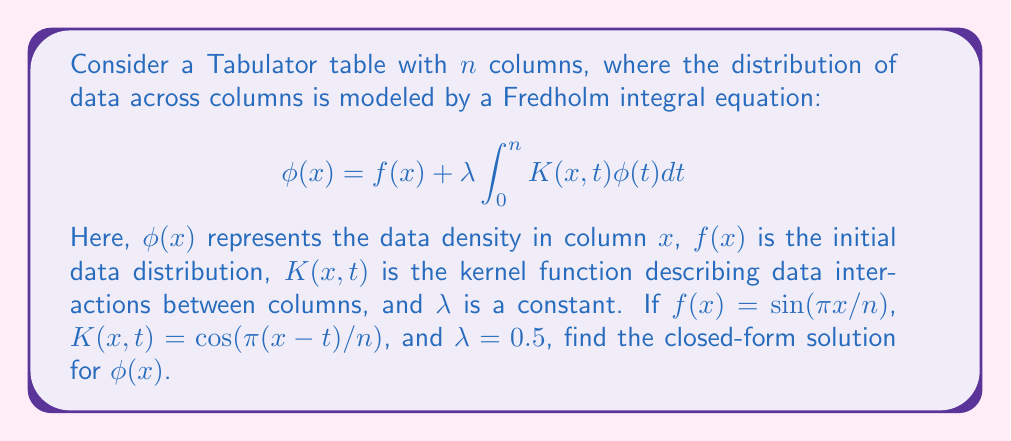Can you answer this question? To solve this Fredholm integral equation, we'll follow these steps:

1) First, we assume that the solution $\phi(x)$ has the same form as $f(x)$:
   $$\phi(x) = A \sin(\pi x/n)$$
   where $A$ is a constant we need to determine.

2) Substitute this assumed solution into the integral equation:
   $$A \sin(\pi x/n) = \sin(\pi x/n) + 0.5 \int_0^n \cos(\pi(x-t)/n) \cdot A \sin(\pi t/n)dt$$

3) Use the trigonometric identity for the product of cosine and sine:
   $$\cos(\pi(x-t)/n) \sin(\pi t/n) = \frac{1}{2}[\sin(\pi x/n) + \sin(\pi(2t-x)/n)]$$

4) Substitute this into the integral:
   $$A \sin(\pi x/n) = \sin(\pi x/n) + 0.25A \int_0^n [\sin(\pi x/n) + \sin(\pi(2t-x)/n)]dt$$

5) Evaluate the integral:
   $$\int_0^n \sin(\pi x/n)dt = n\sin(\pi x/n)$$
   $$\int_0^n \sin(\pi(2t-x)/n)dt = 0$$

6) After integration:
   $$A \sin(\pi x/n) = \sin(\pi x/n) + 0.25An\sin(\pi x/n)$$

7) Factoring out $\sin(\pi x/n)$:
   $$A = 1 + 0.25An$$

8) Solve for $A$:
   $$A - 0.25An = 1$$
   $$A(1 - 0.25n) = 1$$
   $$A = \frac{1}{1 - 0.25n}$$

9) Therefore, the closed-form solution is:
   $$\phi(x) = \frac{1}{1 - 0.25n} \sin(\pi x/n)$$
Answer: $$\phi(x) = \frac{1}{1 - 0.25n} \sin(\pi x/n)$$ 